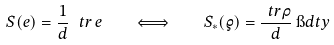Convert formula to latex. <formula><loc_0><loc_0><loc_500><loc_500>S ( e ) = \frac { 1 } { d } \, \ t r { \, e } \quad \Longleftrightarrow \quad S _ { * } ( \varrho ) = \frac { \ t r { \rho } } { d } \, \i d t y</formula> 